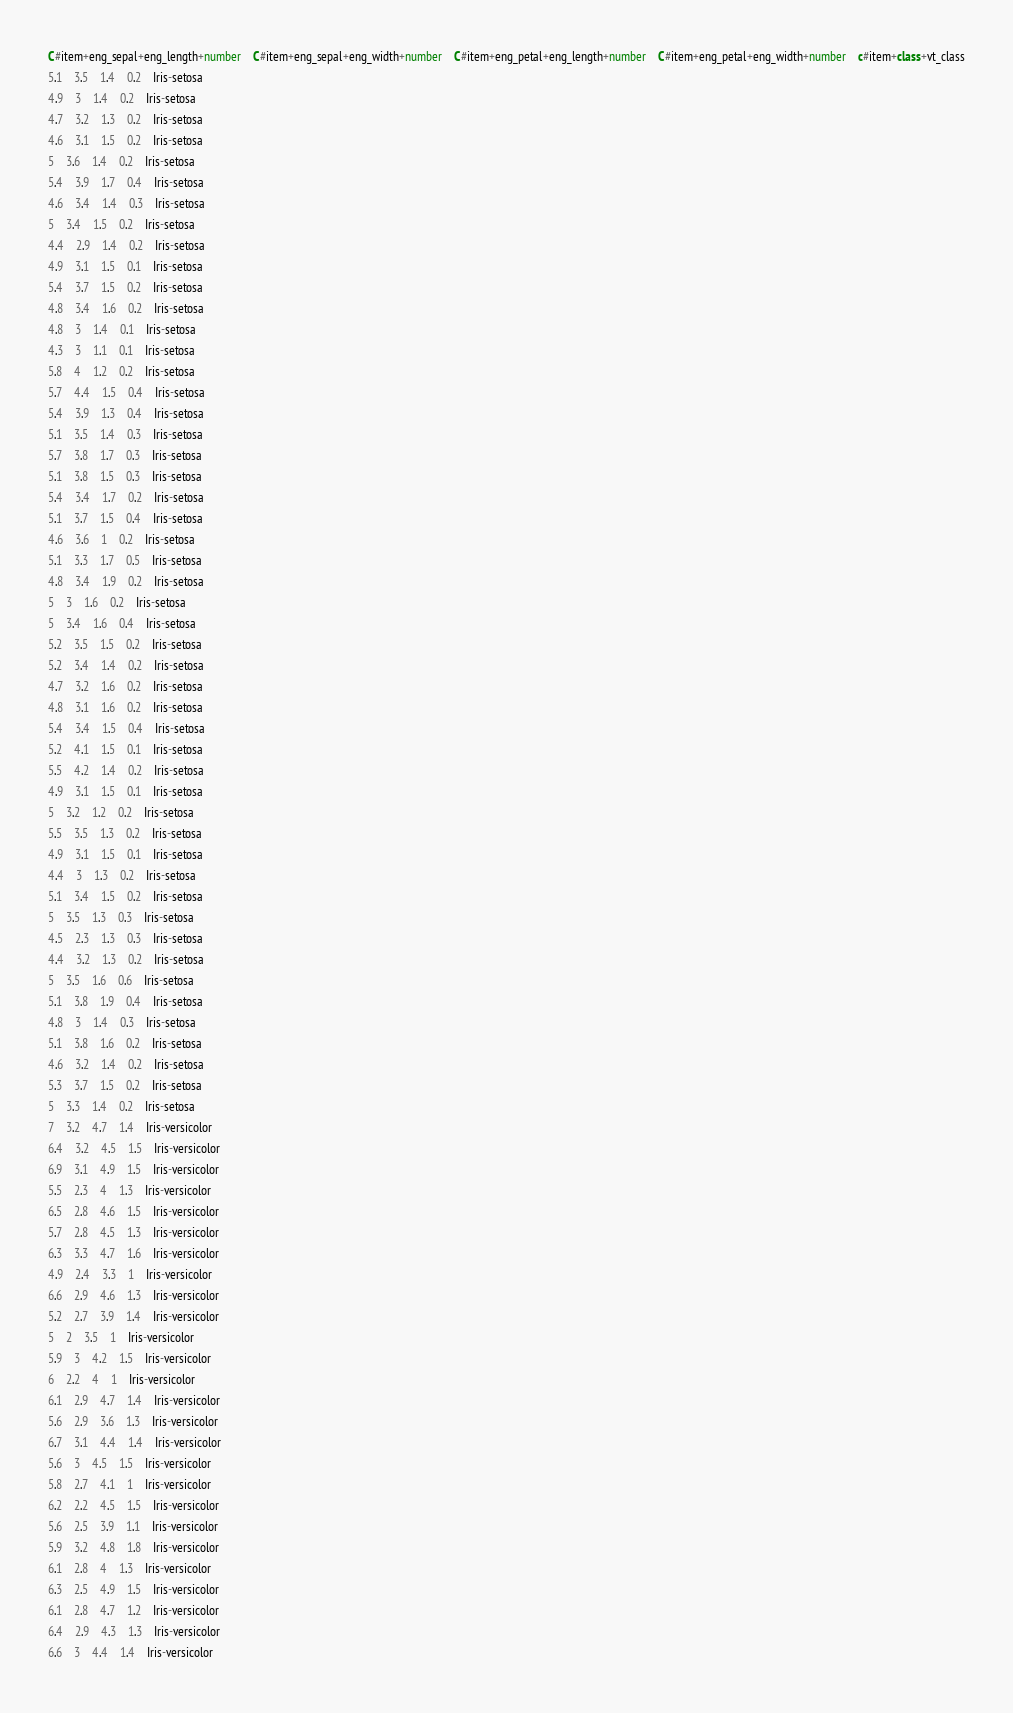<code> <loc_0><loc_0><loc_500><loc_500><_SQL_>C#item+eng_sepal+eng_length+number	C#item+eng_sepal+eng_width+number	C#item+eng_petal+eng_length+number	C#item+eng_petal+eng_width+number	c#item+class+vt_class
5.1	3.5	1.4	0.2	Iris-setosa
4.9	3	1.4	0.2	Iris-setosa
4.7	3.2	1.3	0.2	Iris-setosa
4.6	3.1	1.5	0.2	Iris-setosa
5	3.6	1.4	0.2	Iris-setosa
5.4	3.9	1.7	0.4	Iris-setosa
4.6	3.4	1.4	0.3	Iris-setosa
5	3.4	1.5	0.2	Iris-setosa
4.4	2.9	1.4	0.2	Iris-setosa
4.9	3.1	1.5	0.1	Iris-setosa
5.4	3.7	1.5	0.2	Iris-setosa
4.8	3.4	1.6	0.2	Iris-setosa
4.8	3	1.4	0.1	Iris-setosa
4.3	3	1.1	0.1	Iris-setosa
5.8	4	1.2	0.2	Iris-setosa
5.7	4.4	1.5	0.4	Iris-setosa
5.4	3.9	1.3	0.4	Iris-setosa
5.1	3.5	1.4	0.3	Iris-setosa
5.7	3.8	1.7	0.3	Iris-setosa
5.1	3.8	1.5	0.3	Iris-setosa
5.4	3.4	1.7	0.2	Iris-setosa
5.1	3.7	1.5	0.4	Iris-setosa
4.6	3.6	1	0.2	Iris-setosa
5.1	3.3	1.7	0.5	Iris-setosa
4.8	3.4	1.9	0.2	Iris-setosa
5	3	1.6	0.2	Iris-setosa
5	3.4	1.6	0.4	Iris-setosa
5.2	3.5	1.5	0.2	Iris-setosa
5.2	3.4	1.4	0.2	Iris-setosa
4.7	3.2	1.6	0.2	Iris-setosa
4.8	3.1	1.6	0.2	Iris-setosa
5.4	3.4	1.5	0.4	Iris-setosa
5.2	4.1	1.5	0.1	Iris-setosa
5.5	4.2	1.4	0.2	Iris-setosa
4.9	3.1	1.5	0.1	Iris-setosa
5	3.2	1.2	0.2	Iris-setosa
5.5	3.5	1.3	0.2	Iris-setosa
4.9	3.1	1.5	0.1	Iris-setosa
4.4	3	1.3	0.2	Iris-setosa
5.1	3.4	1.5	0.2	Iris-setosa
5	3.5	1.3	0.3	Iris-setosa
4.5	2.3	1.3	0.3	Iris-setosa
4.4	3.2	1.3	0.2	Iris-setosa
5	3.5	1.6	0.6	Iris-setosa
5.1	3.8	1.9	0.4	Iris-setosa
4.8	3	1.4	0.3	Iris-setosa
5.1	3.8	1.6	0.2	Iris-setosa
4.6	3.2	1.4	0.2	Iris-setosa
5.3	3.7	1.5	0.2	Iris-setosa
5	3.3	1.4	0.2	Iris-setosa
7	3.2	4.7	1.4	Iris-versicolor
6.4	3.2	4.5	1.5	Iris-versicolor
6.9	3.1	4.9	1.5	Iris-versicolor
5.5	2.3	4	1.3	Iris-versicolor
6.5	2.8	4.6	1.5	Iris-versicolor
5.7	2.8	4.5	1.3	Iris-versicolor
6.3	3.3	4.7	1.6	Iris-versicolor
4.9	2.4	3.3	1	Iris-versicolor
6.6	2.9	4.6	1.3	Iris-versicolor
5.2	2.7	3.9	1.4	Iris-versicolor
5	2	3.5	1	Iris-versicolor
5.9	3	4.2	1.5	Iris-versicolor
6	2.2	4	1	Iris-versicolor
6.1	2.9	4.7	1.4	Iris-versicolor
5.6	2.9	3.6	1.3	Iris-versicolor
6.7	3.1	4.4	1.4	Iris-versicolor
5.6	3	4.5	1.5	Iris-versicolor
5.8	2.7	4.1	1	Iris-versicolor
6.2	2.2	4.5	1.5	Iris-versicolor
5.6	2.5	3.9	1.1	Iris-versicolor
5.9	3.2	4.8	1.8	Iris-versicolor
6.1	2.8	4	1.3	Iris-versicolor
6.3	2.5	4.9	1.5	Iris-versicolor
6.1	2.8	4.7	1.2	Iris-versicolor
6.4	2.9	4.3	1.3	Iris-versicolor
6.6	3	4.4	1.4	Iris-versicolor</code> 